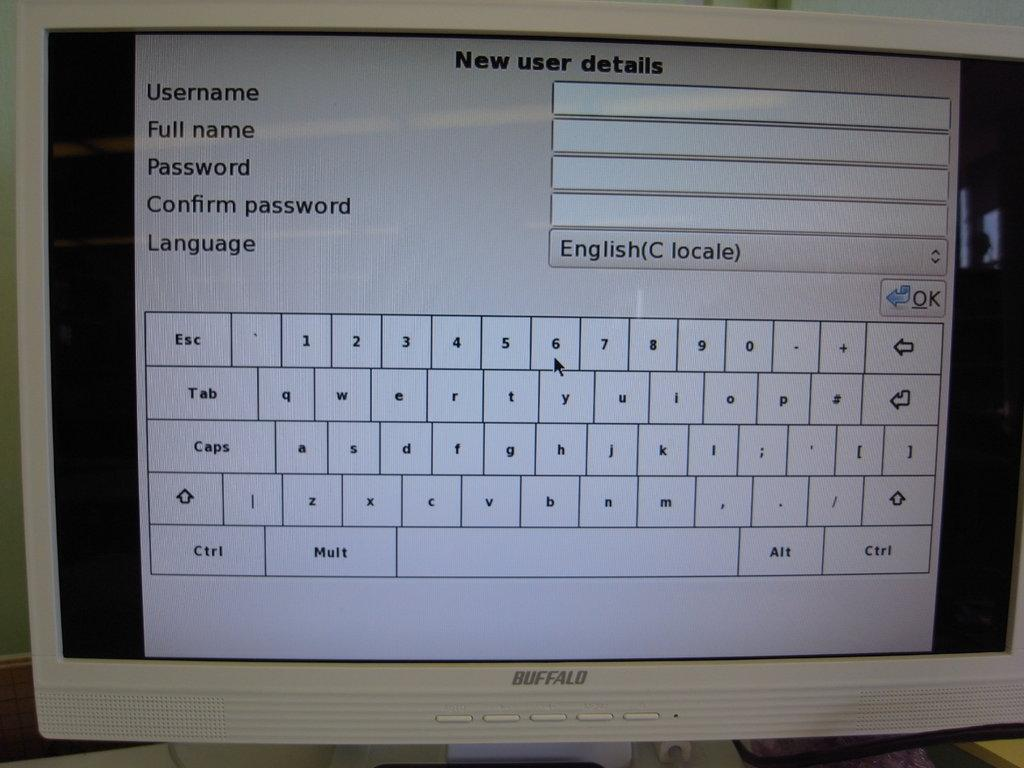<image>
Describe the image concisely. A turned on monitor that is asking for new user details. 